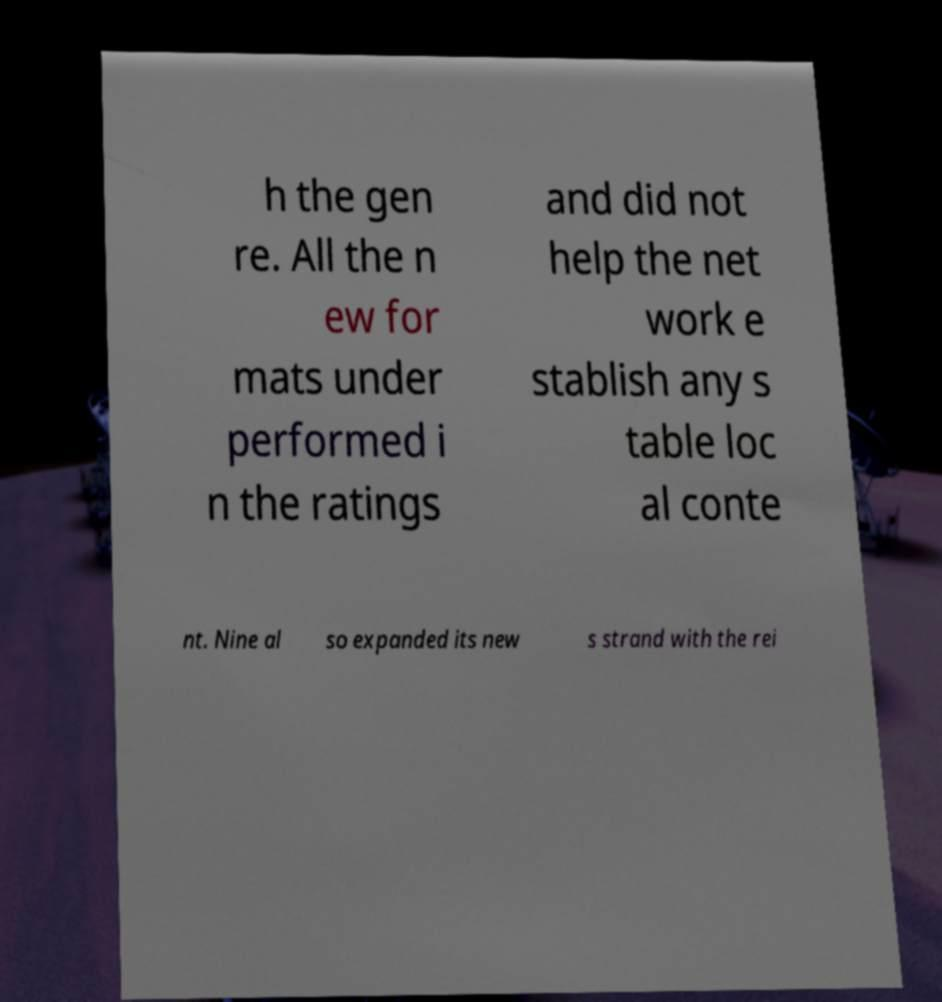Could you extract and type out the text from this image? h the gen re. All the n ew for mats under performed i n the ratings and did not help the net work e stablish any s table loc al conte nt. Nine al so expanded its new s strand with the rei 